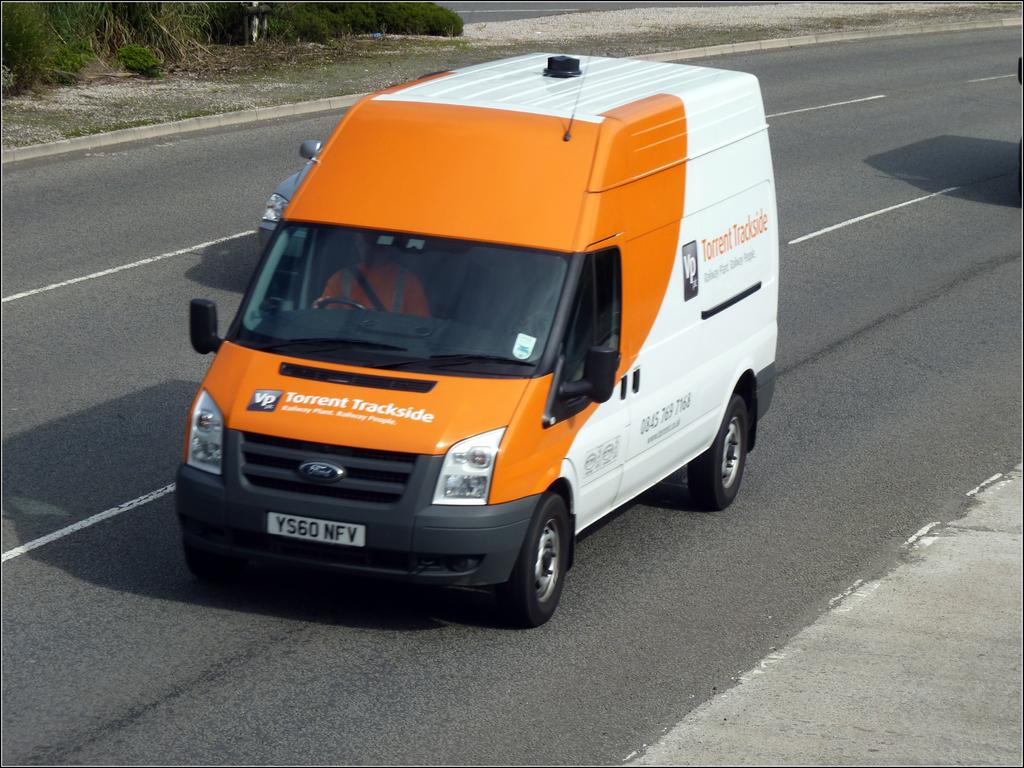Provide a one-sentence caption for the provided image. an orange and white van for Torrent Tracks on the road. 